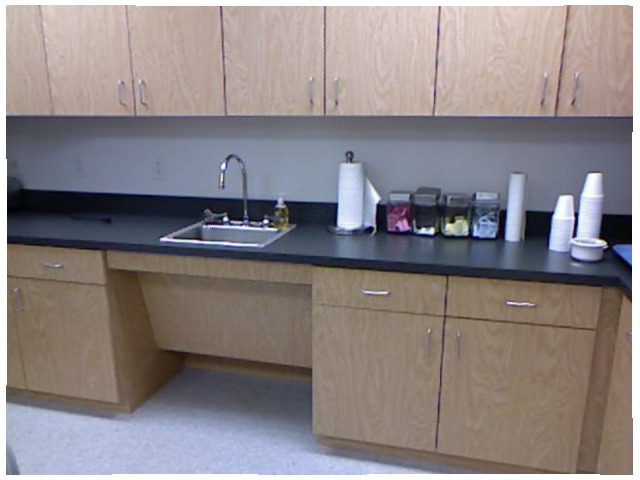<image>
Is there a cup under the cupboard? Yes. The cup is positioned underneath the cupboard, with the cupboard above it in the vertical space. Is the cupboard under the table? No. The cupboard is not positioned under the table. The vertical relationship between these objects is different. Where is the paper roll in relation to the sink? Is it above the sink? No. The paper roll is not positioned above the sink. The vertical arrangement shows a different relationship. 